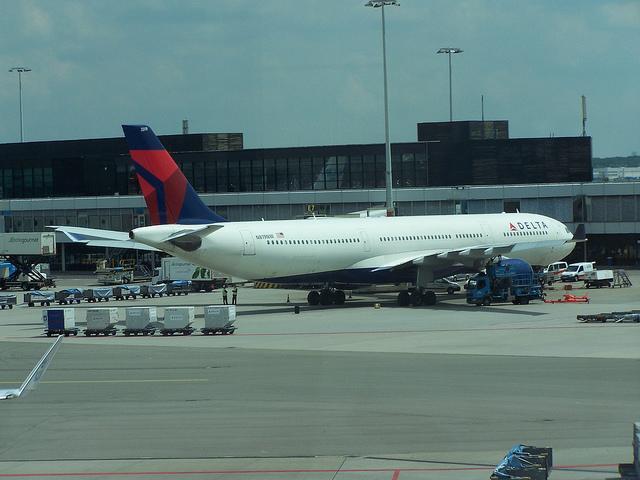How many children are on bicycles in this image?
Give a very brief answer. 0. 